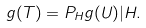Convert formula to latex. <formula><loc_0><loc_0><loc_500><loc_500>g ( T ) = P _ { H } g ( U ) | H .</formula> 